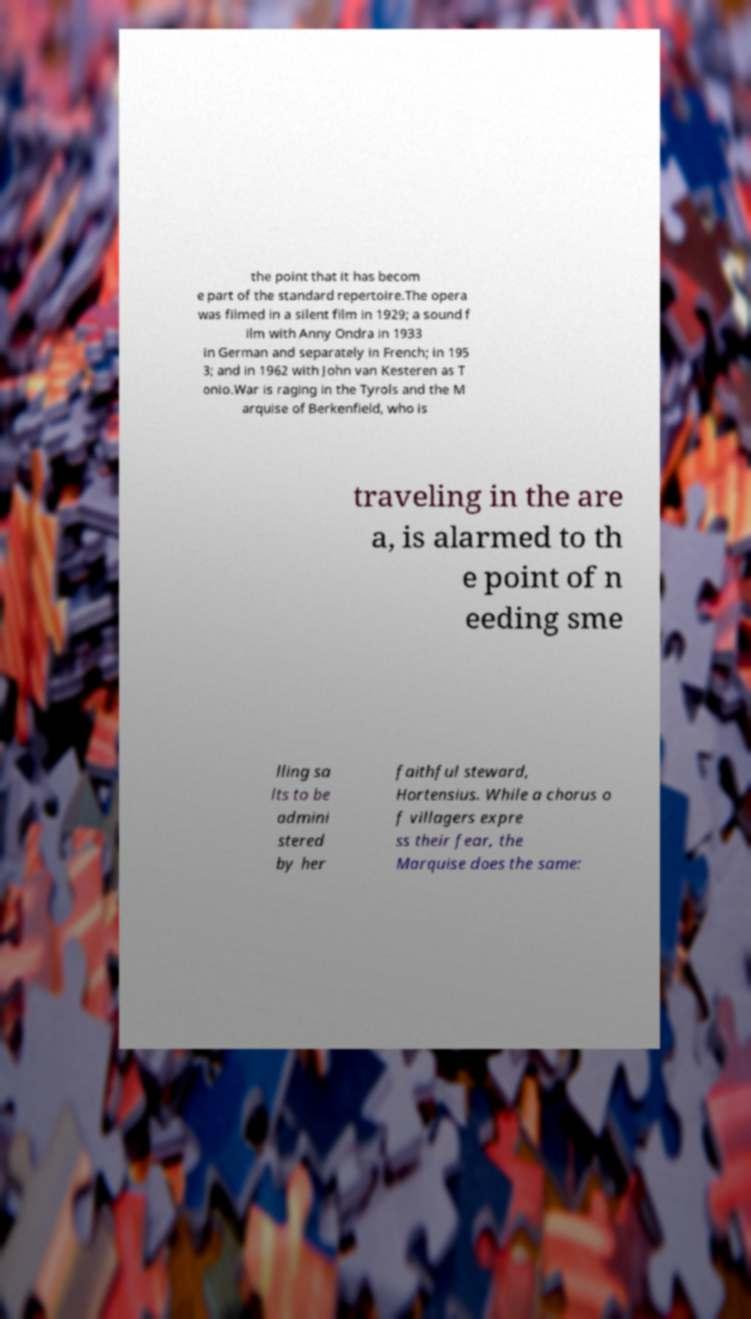What messages or text are displayed in this image? I need them in a readable, typed format. the point that it has becom e part of the standard repertoire.The opera was filmed in a silent film in 1929; a sound f ilm with Anny Ondra in 1933 in German and separately in French; in 195 3; and in 1962 with John van Kesteren as T onio.War is raging in the Tyrols and the M arquise of Berkenfield, who is traveling in the are a, is alarmed to th e point of n eeding sme lling sa lts to be admini stered by her faithful steward, Hortensius. While a chorus o f villagers expre ss their fear, the Marquise does the same: 